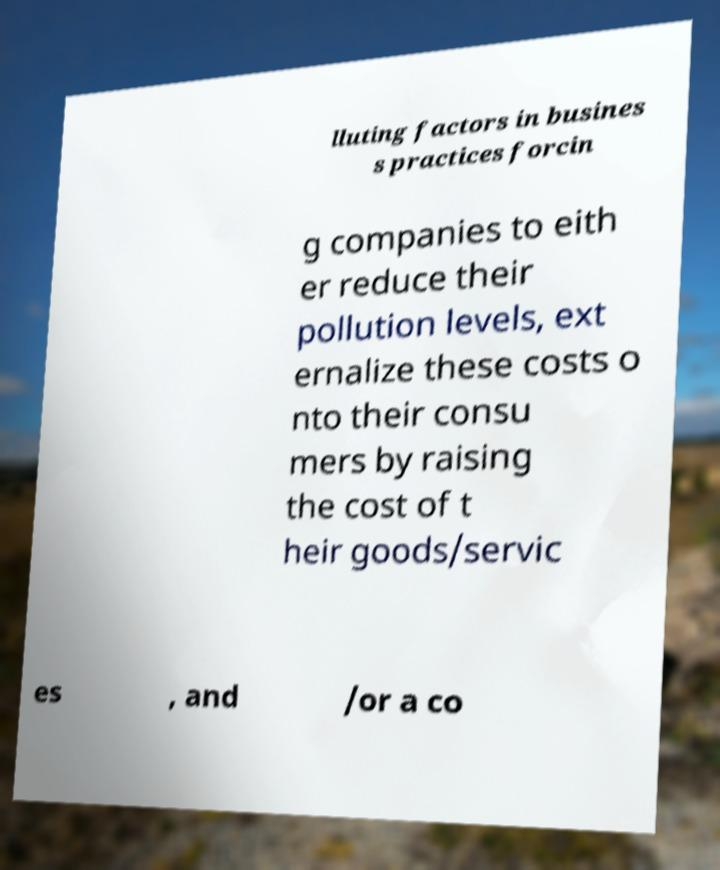Please read and relay the text visible in this image. What does it say? lluting factors in busines s practices forcin g companies to eith er reduce their pollution levels, ext ernalize these costs o nto their consu mers by raising the cost of t heir goods/servic es , and /or a co 